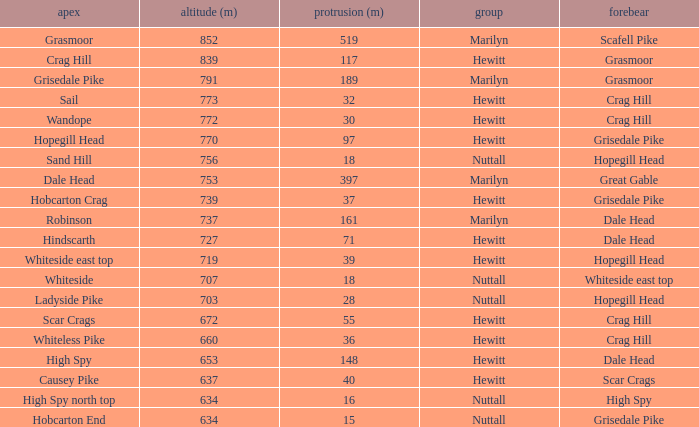What is the lowest height for Parent grasmoor when it has a Prom larger than 117? 791.0. 